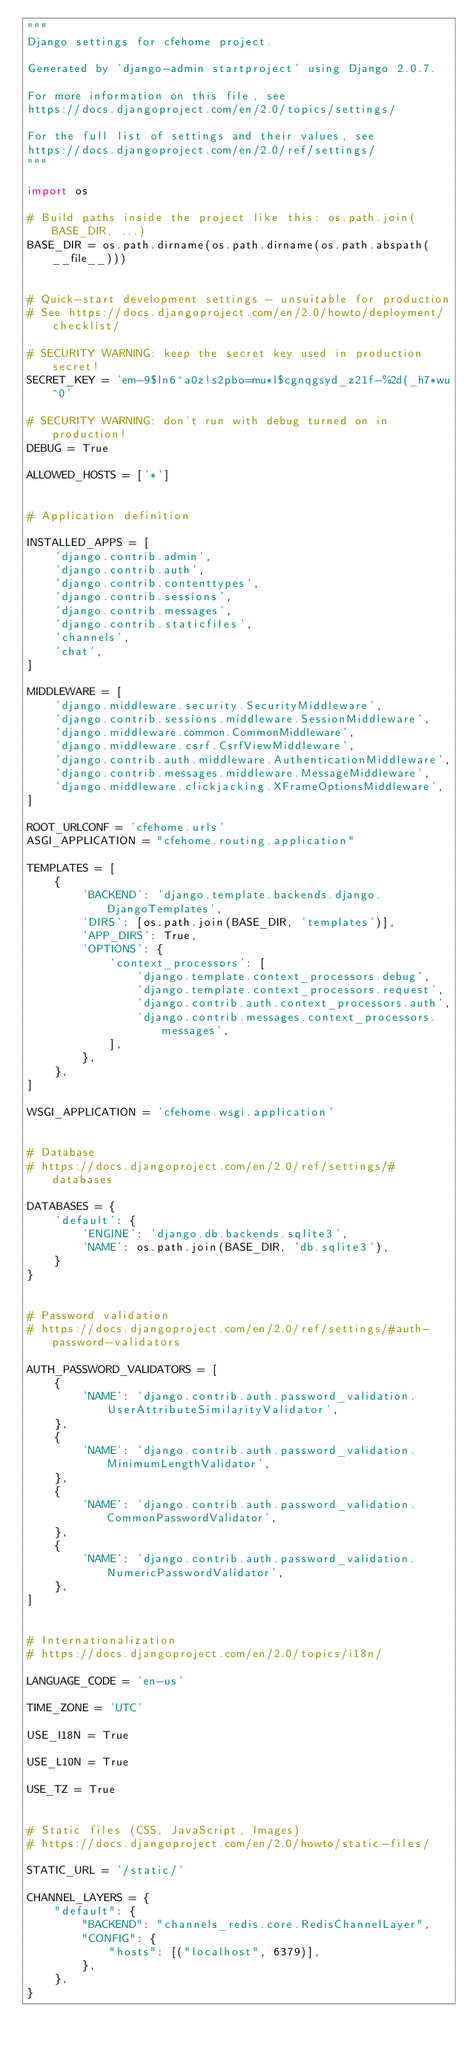<code> <loc_0><loc_0><loc_500><loc_500><_Python_>"""
Django settings for cfehome project.

Generated by 'django-admin startproject' using Django 2.0.7.

For more information on this file, see
https://docs.djangoproject.com/en/2.0/topics/settings/

For the full list of settings and their values, see
https://docs.djangoproject.com/en/2.0/ref/settings/
"""

import os

# Build paths inside the project like this: os.path.join(BASE_DIR, ...)
BASE_DIR = os.path.dirname(os.path.dirname(os.path.abspath(__file__)))


# Quick-start development settings - unsuitable for production
# See https://docs.djangoproject.com/en/2.0/howto/deployment/checklist/

# SECURITY WARNING: keep the secret key used in production secret!
SECRET_KEY = 'em-9$ln6^a0z!s2pbo=mu*l$cgnqgsyd_z21f-%2d(_h7*wu^0'

# SECURITY WARNING: don't run with debug turned on in production!
DEBUG = True

ALLOWED_HOSTS = ['*']


# Application definition

INSTALLED_APPS = [
    'django.contrib.admin',
    'django.contrib.auth',
    'django.contrib.contenttypes',
    'django.contrib.sessions',
    'django.contrib.messages',
    'django.contrib.staticfiles',
    'channels',
    'chat',
]

MIDDLEWARE = [
    'django.middleware.security.SecurityMiddleware',
    'django.contrib.sessions.middleware.SessionMiddleware',
    'django.middleware.common.CommonMiddleware',
    'django.middleware.csrf.CsrfViewMiddleware',
    'django.contrib.auth.middleware.AuthenticationMiddleware',
    'django.contrib.messages.middleware.MessageMiddleware',
    'django.middleware.clickjacking.XFrameOptionsMiddleware',
]

ROOT_URLCONF = 'cfehome.urls'
ASGI_APPLICATION = "cfehome.routing.application"

TEMPLATES = [
    {
        'BACKEND': 'django.template.backends.django.DjangoTemplates',
        'DIRS': [os.path.join(BASE_DIR, 'templates')],
        'APP_DIRS': True,
        'OPTIONS': {
            'context_processors': [
                'django.template.context_processors.debug',
                'django.template.context_processors.request',
                'django.contrib.auth.context_processors.auth',
                'django.contrib.messages.context_processors.messages',
            ],
        },
    },
]

WSGI_APPLICATION = 'cfehome.wsgi.application'


# Database
# https://docs.djangoproject.com/en/2.0/ref/settings/#databases

DATABASES = {
    'default': {
        'ENGINE': 'django.db.backends.sqlite3',
        'NAME': os.path.join(BASE_DIR, 'db.sqlite3'),
    }
}


# Password validation
# https://docs.djangoproject.com/en/2.0/ref/settings/#auth-password-validators

AUTH_PASSWORD_VALIDATORS = [
    {
        'NAME': 'django.contrib.auth.password_validation.UserAttributeSimilarityValidator',
    },
    {
        'NAME': 'django.contrib.auth.password_validation.MinimumLengthValidator',
    },
    {
        'NAME': 'django.contrib.auth.password_validation.CommonPasswordValidator',
    },
    {
        'NAME': 'django.contrib.auth.password_validation.NumericPasswordValidator',
    },
]


# Internationalization
# https://docs.djangoproject.com/en/2.0/topics/i18n/

LANGUAGE_CODE = 'en-us'

TIME_ZONE = 'UTC'

USE_I18N = True

USE_L10N = True

USE_TZ = True


# Static files (CSS, JavaScript, Images)
# https://docs.djangoproject.com/en/2.0/howto/static-files/

STATIC_URL = '/static/'

CHANNEL_LAYERS = {
    "default": {
        "BACKEND": "channels_redis.core.RedisChannelLayer",
        "CONFIG": {
            "hosts": [("localhost", 6379)],
        },
    },
}
</code> 